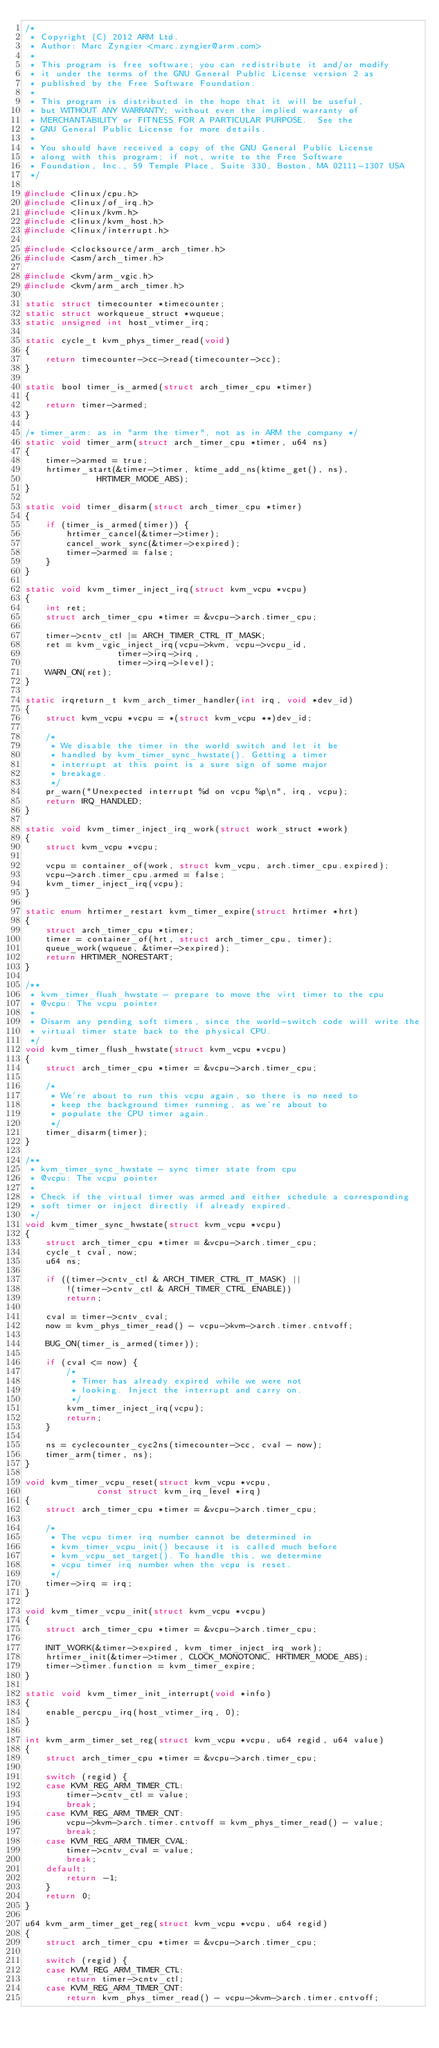Convert code to text. <code><loc_0><loc_0><loc_500><loc_500><_C_>/*
 * Copyright (C) 2012 ARM Ltd.
 * Author: Marc Zyngier <marc.zyngier@arm.com>
 *
 * This program is free software; you can redistribute it and/or modify
 * it under the terms of the GNU General Public License version 2 as
 * published by the Free Software Foundation.
 *
 * This program is distributed in the hope that it will be useful,
 * but WITHOUT ANY WARRANTY; without even the implied warranty of
 * MERCHANTABILITY or FITNESS FOR A PARTICULAR PURPOSE.  See the
 * GNU General Public License for more details.
 *
 * You should have received a copy of the GNU General Public License
 * along with this program; if not, write to the Free Software
 * Foundation, Inc., 59 Temple Place, Suite 330, Boston, MA 02111-1307 USA
 */

#include <linux/cpu.h>
#include <linux/of_irq.h>
#include <linux/kvm.h>
#include <linux/kvm_host.h>
#include <linux/interrupt.h>

#include <clocksource/arm_arch_timer.h>
#include <asm/arch_timer.h>

#include <kvm/arm_vgic.h>
#include <kvm/arm_arch_timer.h>

static struct timecounter *timecounter;
static struct workqueue_struct *wqueue;
static unsigned int host_vtimer_irq;

static cycle_t kvm_phys_timer_read(void)
{
	return timecounter->cc->read(timecounter->cc);
}

static bool timer_is_armed(struct arch_timer_cpu *timer)
{
	return timer->armed;
}

/* timer_arm: as in "arm the timer", not as in ARM the company */
static void timer_arm(struct arch_timer_cpu *timer, u64 ns)
{
	timer->armed = true;
	hrtimer_start(&timer->timer, ktime_add_ns(ktime_get(), ns),
		      HRTIMER_MODE_ABS);
}

static void timer_disarm(struct arch_timer_cpu *timer)
{
	if (timer_is_armed(timer)) {
		hrtimer_cancel(&timer->timer);
		cancel_work_sync(&timer->expired);
		timer->armed = false;
	}
}

static void kvm_timer_inject_irq(struct kvm_vcpu *vcpu)
{
	int ret;
	struct arch_timer_cpu *timer = &vcpu->arch.timer_cpu;

	timer->cntv_ctl |= ARCH_TIMER_CTRL_IT_MASK;
	ret = kvm_vgic_inject_irq(vcpu->kvm, vcpu->vcpu_id,
				  timer->irq->irq,
				  timer->irq->level);
	WARN_ON(ret);
}

static irqreturn_t kvm_arch_timer_handler(int irq, void *dev_id)
{
	struct kvm_vcpu *vcpu = *(struct kvm_vcpu **)dev_id;

	/*
	 * We disable the timer in the world switch and let it be
	 * handled by kvm_timer_sync_hwstate(). Getting a timer
	 * interrupt at this point is a sure sign of some major
	 * breakage.
	 */
	pr_warn("Unexpected interrupt %d on vcpu %p\n", irq, vcpu);
	return IRQ_HANDLED;
}

static void kvm_timer_inject_irq_work(struct work_struct *work)
{
	struct kvm_vcpu *vcpu;

	vcpu = container_of(work, struct kvm_vcpu, arch.timer_cpu.expired);
	vcpu->arch.timer_cpu.armed = false;
	kvm_timer_inject_irq(vcpu);
}

static enum hrtimer_restart kvm_timer_expire(struct hrtimer *hrt)
{
	struct arch_timer_cpu *timer;
	timer = container_of(hrt, struct arch_timer_cpu, timer);
	queue_work(wqueue, &timer->expired);
	return HRTIMER_NORESTART;
}

/**
 * kvm_timer_flush_hwstate - prepare to move the virt timer to the cpu
 * @vcpu: The vcpu pointer
 *
 * Disarm any pending soft timers, since the world-switch code will write the
 * virtual timer state back to the physical CPU.
 */
void kvm_timer_flush_hwstate(struct kvm_vcpu *vcpu)
{
	struct arch_timer_cpu *timer = &vcpu->arch.timer_cpu;

	/*
	 * We're about to run this vcpu again, so there is no need to
	 * keep the background timer running, as we're about to
	 * populate the CPU timer again.
	 */
	timer_disarm(timer);
}

/**
 * kvm_timer_sync_hwstate - sync timer state from cpu
 * @vcpu: The vcpu pointer
 *
 * Check if the virtual timer was armed and either schedule a corresponding
 * soft timer or inject directly if already expired.
 */
void kvm_timer_sync_hwstate(struct kvm_vcpu *vcpu)
{
	struct arch_timer_cpu *timer = &vcpu->arch.timer_cpu;
	cycle_t cval, now;
	u64 ns;

	if ((timer->cntv_ctl & ARCH_TIMER_CTRL_IT_MASK) ||
		!(timer->cntv_ctl & ARCH_TIMER_CTRL_ENABLE))
		return;

	cval = timer->cntv_cval;
	now = kvm_phys_timer_read() - vcpu->kvm->arch.timer.cntvoff;

	BUG_ON(timer_is_armed(timer));

	if (cval <= now) {
		/*
		 * Timer has already expired while we were not
		 * looking. Inject the interrupt and carry on.
		 */
		kvm_timer_inject_irq(vcpu);
		return;
	}

	ns = cyclecounter_cyc2ns(timecounter->cc, cval - now);
	timer_arm(timer, ns);
}

void kvm_timer_vcpu_reset(struct kvm_vcpu *vcpu,
			  const struct kvm_irq_level *irq)
{
	struct arch_timer_cpu *timer = &vcpu->arch.timer_cpu;

	/*
	 * The vcpu timer irq number cannot be determined in
	 * kvm_timer_vcpu_init() because it is called much before
	 * kvm_vcpu_set_target(). To handle this, we determine
	 * vcpu timer irq number when the vcpu is reset.
	 */
	timer->irq = irq;
}

void kvm_timer_vcpu_init(struct kvm_vcpu *vcpu)
{
	struct arch_timer_cpu *timer = &vcpu->arch.timer_cpu;

	INIT_WORK(&timer->expired, kvm_timer_inject_irq_work);
	hrtimer_init(&timer->timer, CLOCK_MONOTONIC, HRTIMER_MODE_ABS);
	timer->timer.function = kvm_timer_expire;
}

static void kvm_timer_init_interrupt(void *info)
{
	enable_percpu_irq(host_vtimer_irq, 0);
}

int kvm_arm_timer_set_reg(struct kvm_vcpu *vcpu, u64 regid, u64 value)
{
	struct arch_timer_cpu *timer = &vcpu->arch.timer_cpu;

	switch (regid) {
	case KVM_REG_ARM_TIMER_CTL:
		timer->cntv_ctl = value;
		break;
	case KVM_REG_ARM_TIMER_CNT:
		vcpu->kvm->arch.timer.cntvoff = kvm_phys_timer_read() - value;
		break;
	case KVM_REG_ARM_TIMER_CVAL:
		timer->cntv_cval = value;
		break;
	default:
		return -1;
	}
	return 0;
}

u64 kvm_arm_timer_get_reg(struct kvm_vcpu *vcpu, u64 regid)
{
	struct arch_timer_cpu *timer = &vcpu->arch.timer_cpu;

	switch (regid) {
	case KVM_REG_ARM_TIMER_CTL:
		return timer->cntv_ctl;
	case KVM_REG_ARM_TIMER_CNT:
		return kvm_phys_timer_read() - vcpu->kvm->arch.timer.cntvoff;</code> 